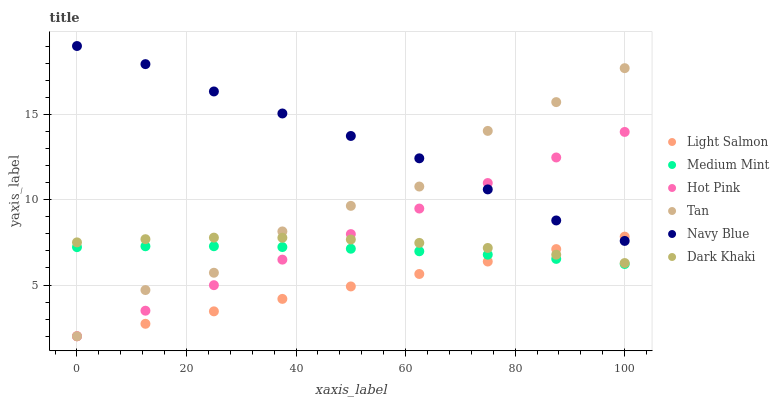Does Light Salmon have the minimum area under the curve?
Answer yes or no. Yes. Does Navy Blue have the maximum area under the curve?
Answer yes or no. Yes. Does Navy Blue have the minimum area under the curve?
Answer yes or no. No. Does Light Salmon have the maximum area under the curve?
Answer yes or no. No. Is Light Salmon the smoothest?
Answer yes or no. Yes. Is Tan the roughest?
Answer yes or no. Yes. Is Navy Blue the smoothest?
Answer yes or no. No. Is Navy Blue the roughest?
Answer yes or no. No. Does Light Salmon have the lowest value?
Answer yes or no. Yes. Does Navy Blue have the lowest value?
Answer yes or no. No. Does Navy Blue have the highest value?
Answer yes or no. Yes. Does Light Salmon have the highest value?
Answer yes or no. No. Is Medium Mint less than Navy Blue?
Answer yes or no. Yes. Is Navy Blue greater than Dark Khaki?
Answer yes or no. Yes. Does Hot Pink intersect Tan?
Answer yes or no. Yes. Is Hot Pink less than Tan?
Answer yes or no. No. Is Hot Pink greater than Tan?
Answer yes or no. No. Does Medium Mint intersect Navy Blue?
Answer yes or no. No. 